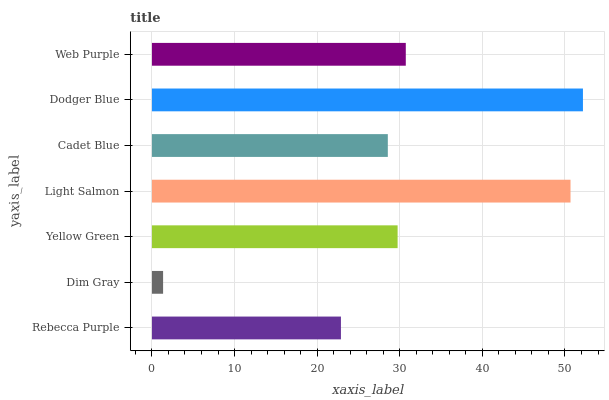Is Dim Gray the minimum?
Answer yes or no. Yes. Is Dodger Blue the maximum?
Answer yes or no. Yes. Is Yellow Green the minimum?
Answer yes or no. No. Is Yellow Green the maximum?
Answer yes or no. No. Is Yellow Green greater than Dim Gray?
Answer yes or no. Yes. Is Dim Gray less than Yellow Green?
Answer yes or no. Yes. Is Dim Gray greater than Yellow Green?
Answer yes or no. No. Is Yellow Green less than Dim Gray?
Answer yes or no. No. Is Yellow Green the high median?
Answer yes or no. Yes. Is Yellow Green the low median?
Answer yes or no. Yes. Is Cadet Blue the high median?
Answer yes or no. No. Is Dodger Blue the low median?
Answer yes or no. No. 